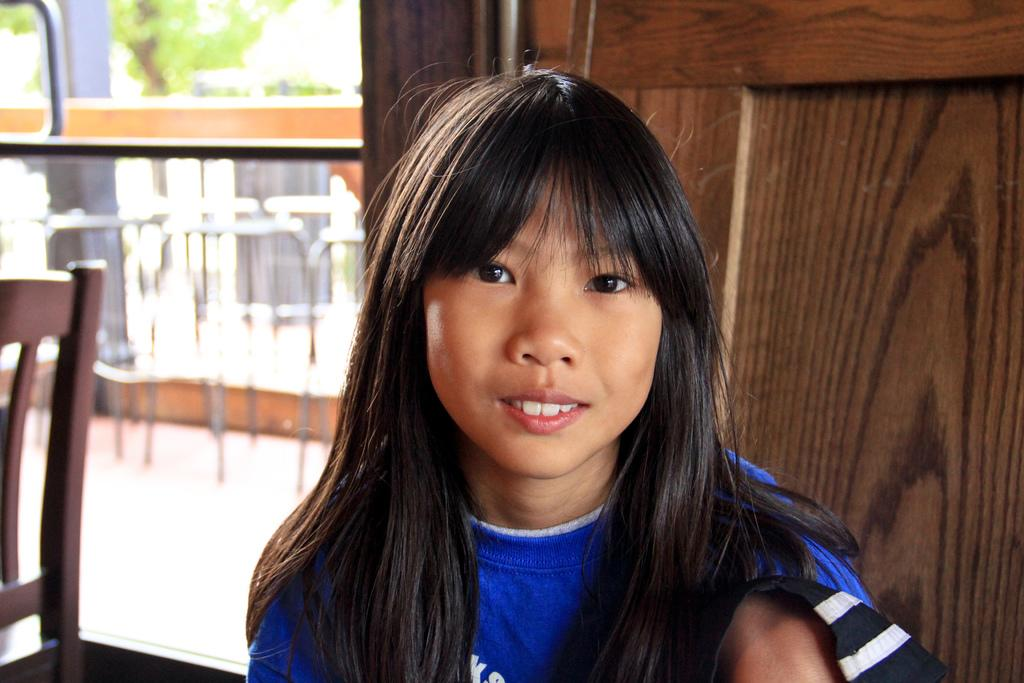Who is the main subject in the image? There is a girl sitting in the center of the image. What can be seen in the background of the image? There is a door and chairs visible in the background of the image. What type of songs can be heard coming from the girl in the image? There is no indication in the image that the girl is singing or that any songs are being played. 